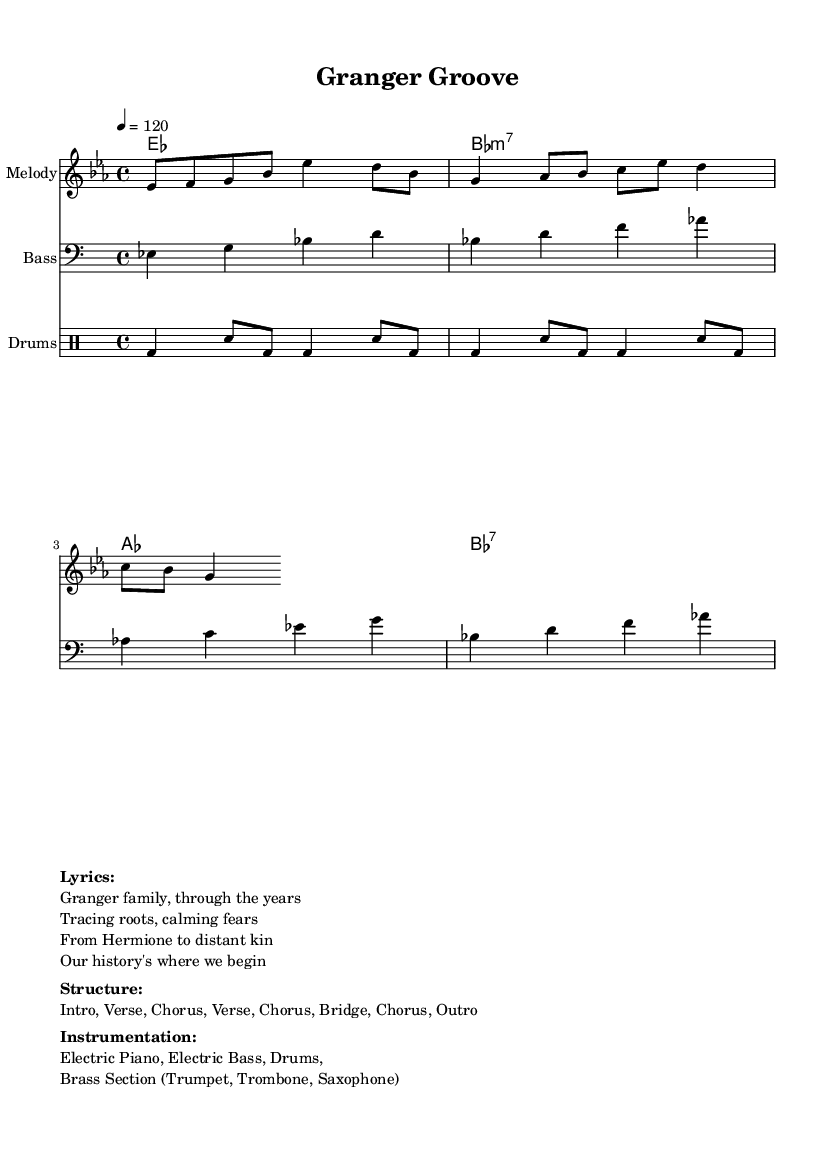What is the key signature of this music? The key signature is E flat major, which is indicated by the presence of three flats (B flat, E flat, and A flat). This is seen at the beginning of the sheet music.
Answer: E flat major What is the time signature of this tune? The time signature is 4/4, meaning there are four beats in each measure and a quarter note gets the beat. This is also specified at the beginning of the sheet music.
Answer: 4/4 What is the tempo marking of the piece? The tempo marking indicates that the piece should be played at a speed of 120 beats per minute, which is shown next to the \tempo directive.
Answer: 120 How many verses are in the structure of the music? The structure outlines two verses in the arrangement: "Intro, Verse, Chorus, Verse, Chorus, Bridge, Chorus, Outro." This shows that the verses occur twice.
Answer: 2 What kind of drums are used in the percussion part? The percussion part includes a bass drum and a snare drum, as indicated by the notation used in the drums part.
Answer: Bass drum and snare drum What instruments are featured in the instrumentation? The instrumentation of the piece includes Electric Piano, Electric Bass, Drums, and a Brass Section comprising Trumpet, Trombone, and Saxophone. This list is outlined in the sheet music details.
Answer: Electric Piano, Electric Bass, Drums, Brass Section What is the primary theme of the lyrics? The lyrics focus on the Granger family's history and genealogy, with a specific emphasis on tracing their roots over the years. This theme is evident in the provided lines of the lyrics.
Answer: Family history 